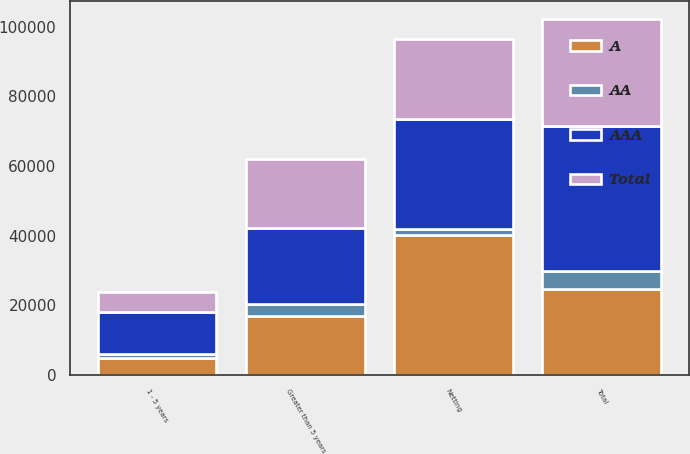<chart> <loc_0><loc_0><loc_500><loc_500><stacked_bar_chart><ecel><fcel>1 - 5 years<fcel>Greater than 5 years<fcel>Total<fcel>Netting<nl><fcel>AA<fcel>1231<fcel>3263<fcel>5157<fcel>1860<nl><fcel>A<fcel>4770<fcel>16990<fcel>24788<fcel>40095<nl><fcel>AAA<fcel>11975<fcel>21857<fcel>41638<fcel>31644<nl><fcel>Total<fcel>5841<fcel>19993<fcel>30569<fcel>22894<nl></chart> 